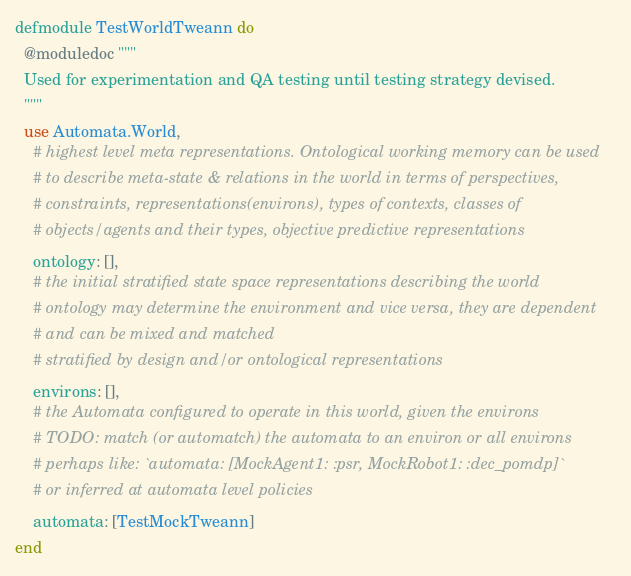Convert code to text. <code><loc_0><loc_0><loc_500><loc_500><_Elixir_>defmodule TestWorldTweann do
  @moduledoc """
  Used for experimentation and QA testing until testing strategy devised.
  """
  use Automata.World,
    # highest level meta representations. Ontological working memory can be used
    # to describe meta-state & relations in the world in terms of perspectives,
    # constraints, representations(environs), types of contexts, classes of
    # objects/agents and their types, objective predictive representations
    ontology: [],
    # the initial stratified state space representations describing the world
    # ontology may determine the environment and vice versa, they are dependent
    # and can be mixed and matched
    # stratified by design and/or ontological representations
    environs: [],
    # the Automata configured to operate in this world, given the environs
    # TODO: match (or automatch) the automata to an environ or all environs
    # perhaps like: `automata: [MockAgent1: :psr, MockRobot1: :dec_pomdp]`
    # or inferred at automata level policies
    automata: [TestMockTweann]
end
</code> 